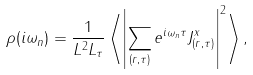Convert formula to latex. <formula><loc_0><loc_0><loc_500><loc_500>\rho ( i \omega _ { n } ) = \frac { 1 } { L ^ { 2 } L _ { \tau } } \left \langle \left | \sum _ { ( { r } , \tau ) } e ^ { i \omega _ { n } \tau } J ^ { x } _ { ( { r } , \tau ) } \right | ^ { 2 } \right \rangle ,</formula> 